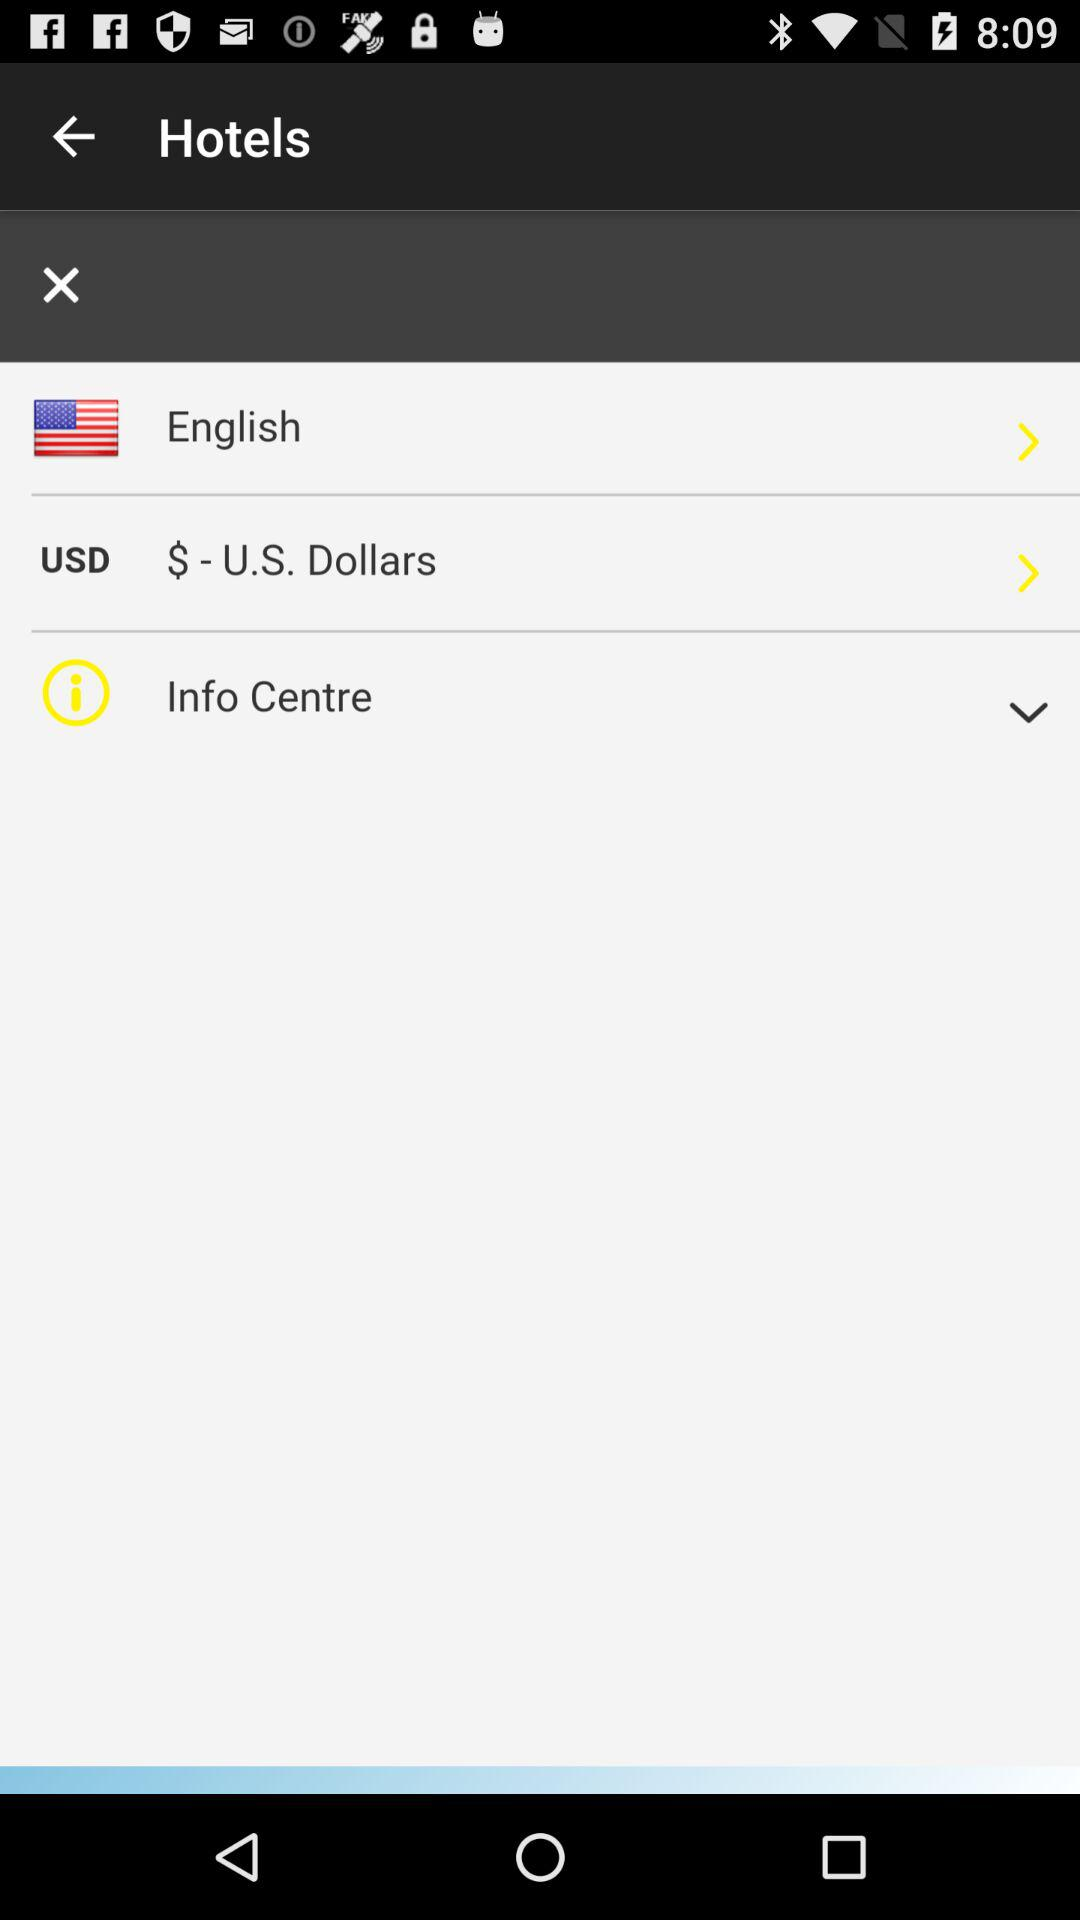Which is the language? The language selected in the displayed mobile app interface is English, which can be seen highlighted under the language options. This setting likely dictates the language used for app interfaces and user interactions. 